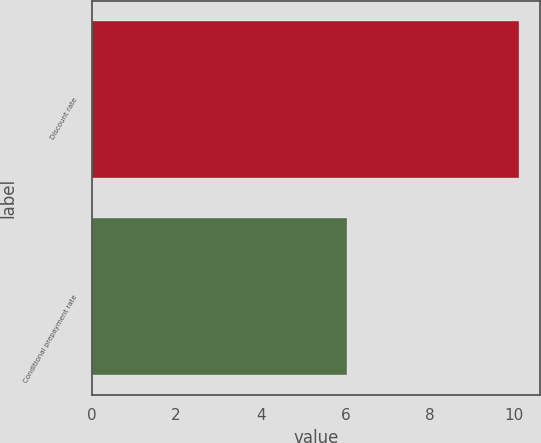Convert chart to OTSL. <chart><loc_0><loc_0><loc_500><loc_500><bar_chart><fcel>Discount rate<fcel>Conditional prepayment rate<nl><fcel>10.11<fcel>6.03<nl></chart> 